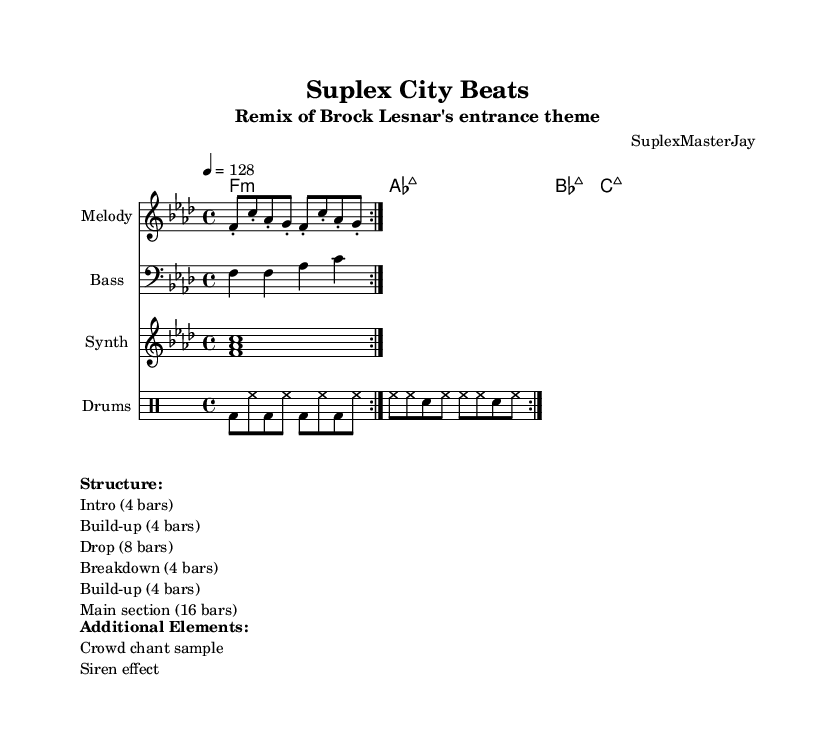What is the key signature of this music? The key signature is F minor, which contains four flats (B, E, A, D). This can be deduced from the global section of the code where it is specified.
Answer: F minor What is the time signature of this music? The time signature is 4/4, which indicates four beats per measure and is indicated in the global section of the code.
Answer: 4/4 What is the tempo marking for this music? The tempo marking is 128 beats per minute, which is specified in the global section of the code.
Answer: 128 How many bars are in the main section of the structure? The main section consists of 16 bars, as outlined in the structure markup towards the end of the code.
Answer: 16 bars What type of drum pattern is indicated in this music? The drum pattern consists of bass drum and hi-hat sequences, as seen in the drumPatterns section. This reflects common house music influences in its rhythmic structure.
Answer: Bass and hi-hat What is the first chord in the sequence? The first chord in the chordNames section is F minor, indicated at the beginning of the chord progression.
Answer: F minor What is one additional element included in the music? One additional element is a crowd chant sample, listed in the Additional Elements section of the markup.
Answer: Crowd chant sample 